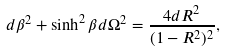<formula> <loc_0><loc_0><loc_500><loc_500>d { \beta } ^ { 2 } + \sinh ^ { 2 } \beta d { \Omega } ^ { 2 } = \frac { 4 { d R } ^ { 2 } } { ( 1 - { R } ^ { 2 } ) ^ { 2 } } ,</formula> 